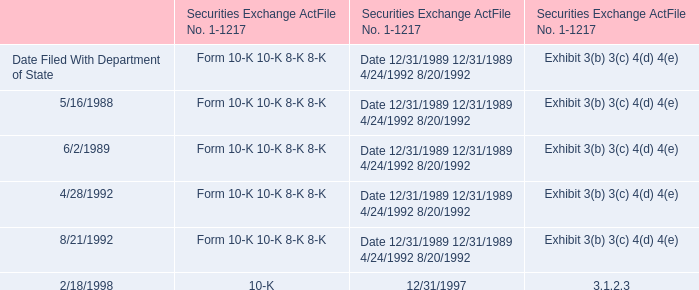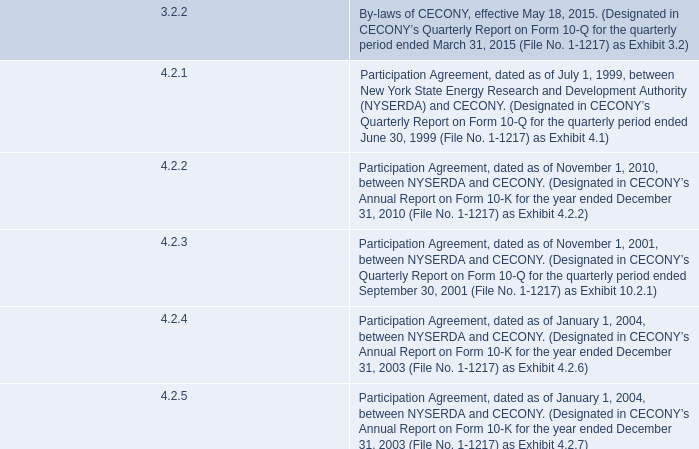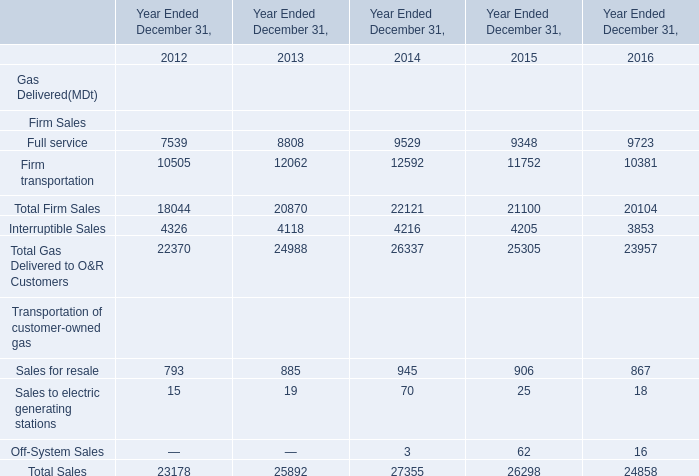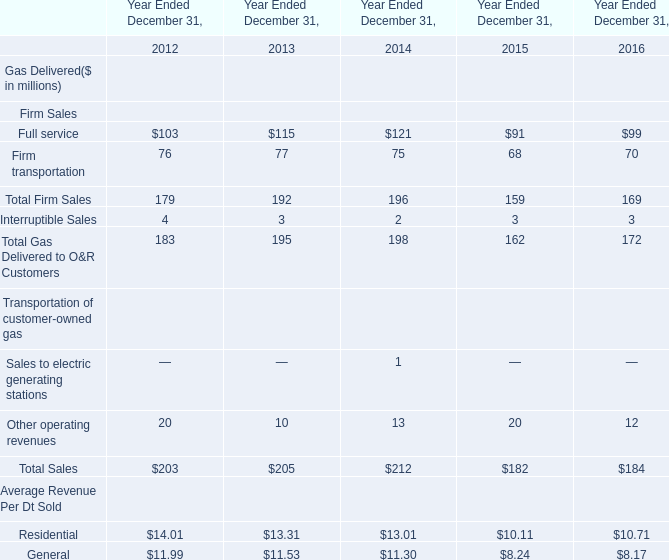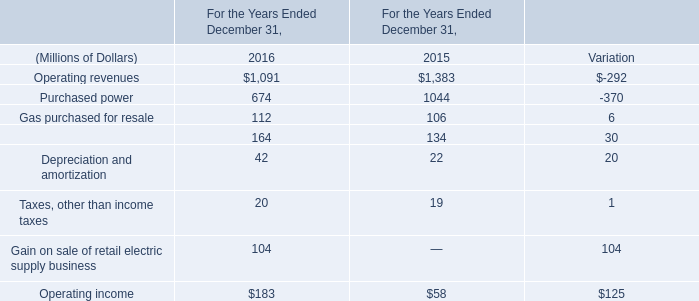What is the proportion of Sales for resale to the total in 2012 ? (in million) 
Computations: (793 / 23178)
Answer: 0.03421. 